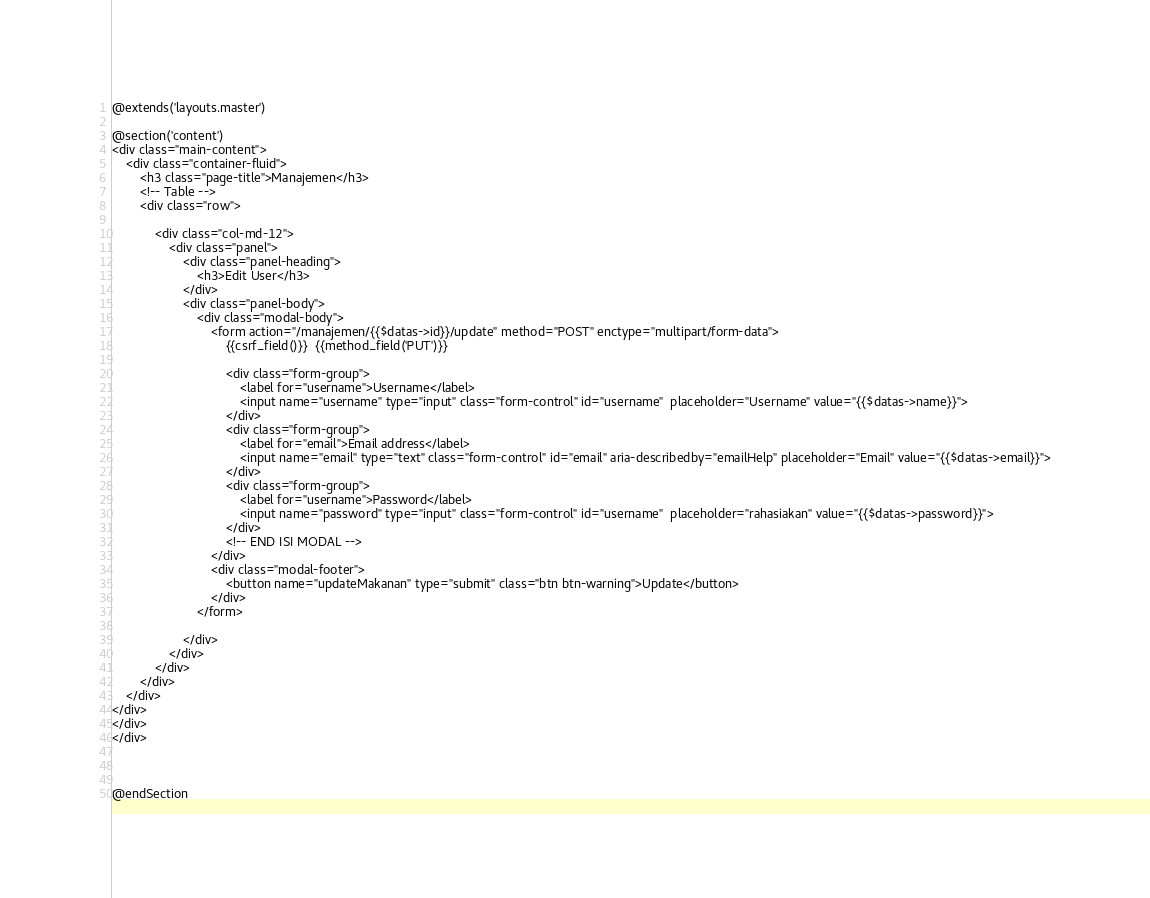Convert code to text. <code><loc_0><loc_0><loc_500><loc_500><_PHP_>@extends('layouts.master')

@section('content')
<div class="main-content">
	<div class="container-fluid">
		<h3 class="page-title">Manajemen</h3>
		<!-- Table -->
		<div class="row">

			<div class="col-md-12">
				<div class="panel">
					<div class="panel-heading">
						<h3>Edit User</h3>
					</div>
					<div class="panel-body">
						<div class="modal-body">
							<form action="/manajemen/{{$datas->id}}/update" method="POST" enctype="multipart/form-data">
								{{csrf_field()}}  {{method_field('PUT')}}

								<div class="form-group">
									<label for="username">Username</label>
									<input name="username" type="input" class="form-control" id="username"  placeholder="Username" value="{{$datas->name}}">
								</div>
								<div class="form-group">
									<label for="email">Email address</label>
									<input name="email" type="text" class="form-control" id="email" aria-describedby="emailHelp" placeholder="Email" value="{{$datas->email}}">
								</div>
								<div class="form-group">
									<label for="username">Password</label>
									<input name="password" type="input" class="form-control" id="username"  placeholder="rahasiakan" value="{{$datas->password}}">
								</div>	
								<!-- END ISI MODAL -->
							</div>
							<div class="modal-footer">
								<button name="updateMakanan" type="submit" class="btn btn-warning">Update</button>
							</div>
						</form>

					</div>
				</div>
			</div>
		</div>
	</div>
</div>
</div>
</div>



@endSection</code> 